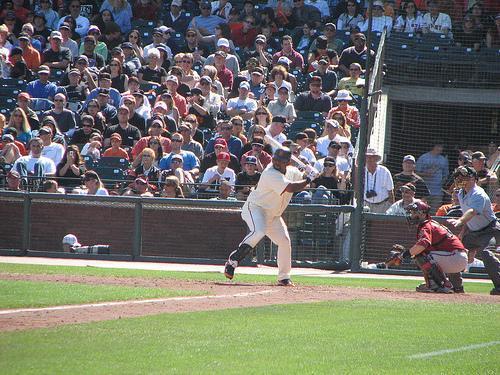How many umpires are in the photo?
Give a very brief answer. 1. 